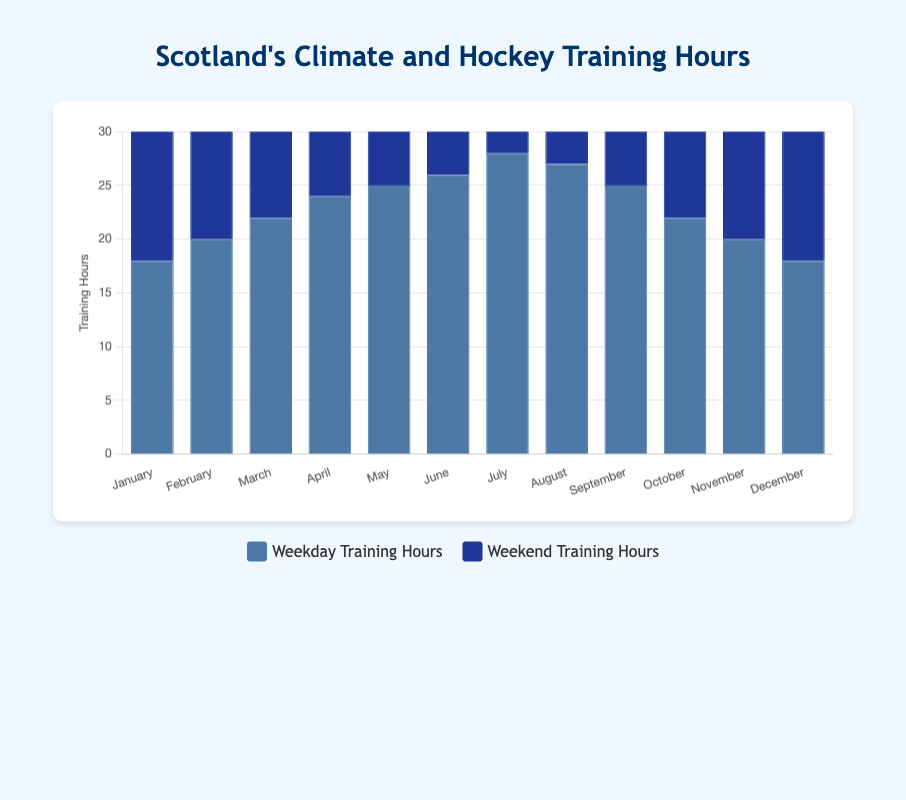What's the total peak training hours in March? To find the total peak training hours in March, we add the weekdays' training hours and weekends' training hours for March. The weekdays' training hours are 22 and the weekends' training hours are 18. So, 22 + 18 = 40.
Answer: 40 Which month has the highest weekday training hours? To find the month with the highest weekday training hours, we compare the weekday training hours across all months. July has the highest weekday training hours at 28 hours.
Answer: July Is the average temperature higher in February or in November? To find this, we compare the average temperatures of February and November. February has an average temperature of 4.5°C, and November has an average temperature of 7.0°C. Since 7.0°C is greater than 4.5°C, November has a higher average temperature.
Answer: November What's the difference in total peak training hours between July and January? To find the difference, we first calculate the total peak training hours for July and January. In July, the weekdays' training hours are 28 and weekends' training hours are 25, so the total is 28 + 25 = 53. In January, the weekdays' training hours are 18 and weekends' training hours are 15, so the total is 18 + 15 = 33. The difference is 53 - 33 = 20.
Answer: 20 How many months have an average temperature above 10°C? To find the number of months with an average temperature above 10°C, we count the months that meet this criterion. The months are May, June, July, August, and October. There are 5 such months.
Answer: 5 Which month has the lowest weekend training hours? To find the month with the lowest weekend training hours, we compare the weekend training hours of all months. January has the lowest weekend training hours, which are 15 hours.
Answer: January What is the sum of weekday training hours in the first half of the year (January to June)? To find the sum, we add the weekday training hours from January to June. They are 18 (January) + 20 (February) + 22 (March) + 24 (April) + 25 (May) + 26 (June). Thus, 18 + 20 + 22 + 24 + 25 + 26 = 135.
Answer: 135 Compare the average temperature of January and December. Are they equal? To compare the average temperatures of January and December, we look at the provided data. January has an average temperature of 4.0°C, and December has an average temperature of 4.5°C. Since 4.0°C is not equal to 4.5°C, they are not equal.
Answer: No Which has more training hours on weekends: the month with the highest average temperature or the month with the lowest average temperature? First, identify the month with the highest average temperature (July, 16.0°C) and the month with the lowest average temperature (January and December, both 4.0°C and 4.5°C respectively). July has 25 weekend training hours, while January has 15 and December has 16. Comparing these, July has more weekend training hours.
Answer: The month with the highest average temperature (July) 